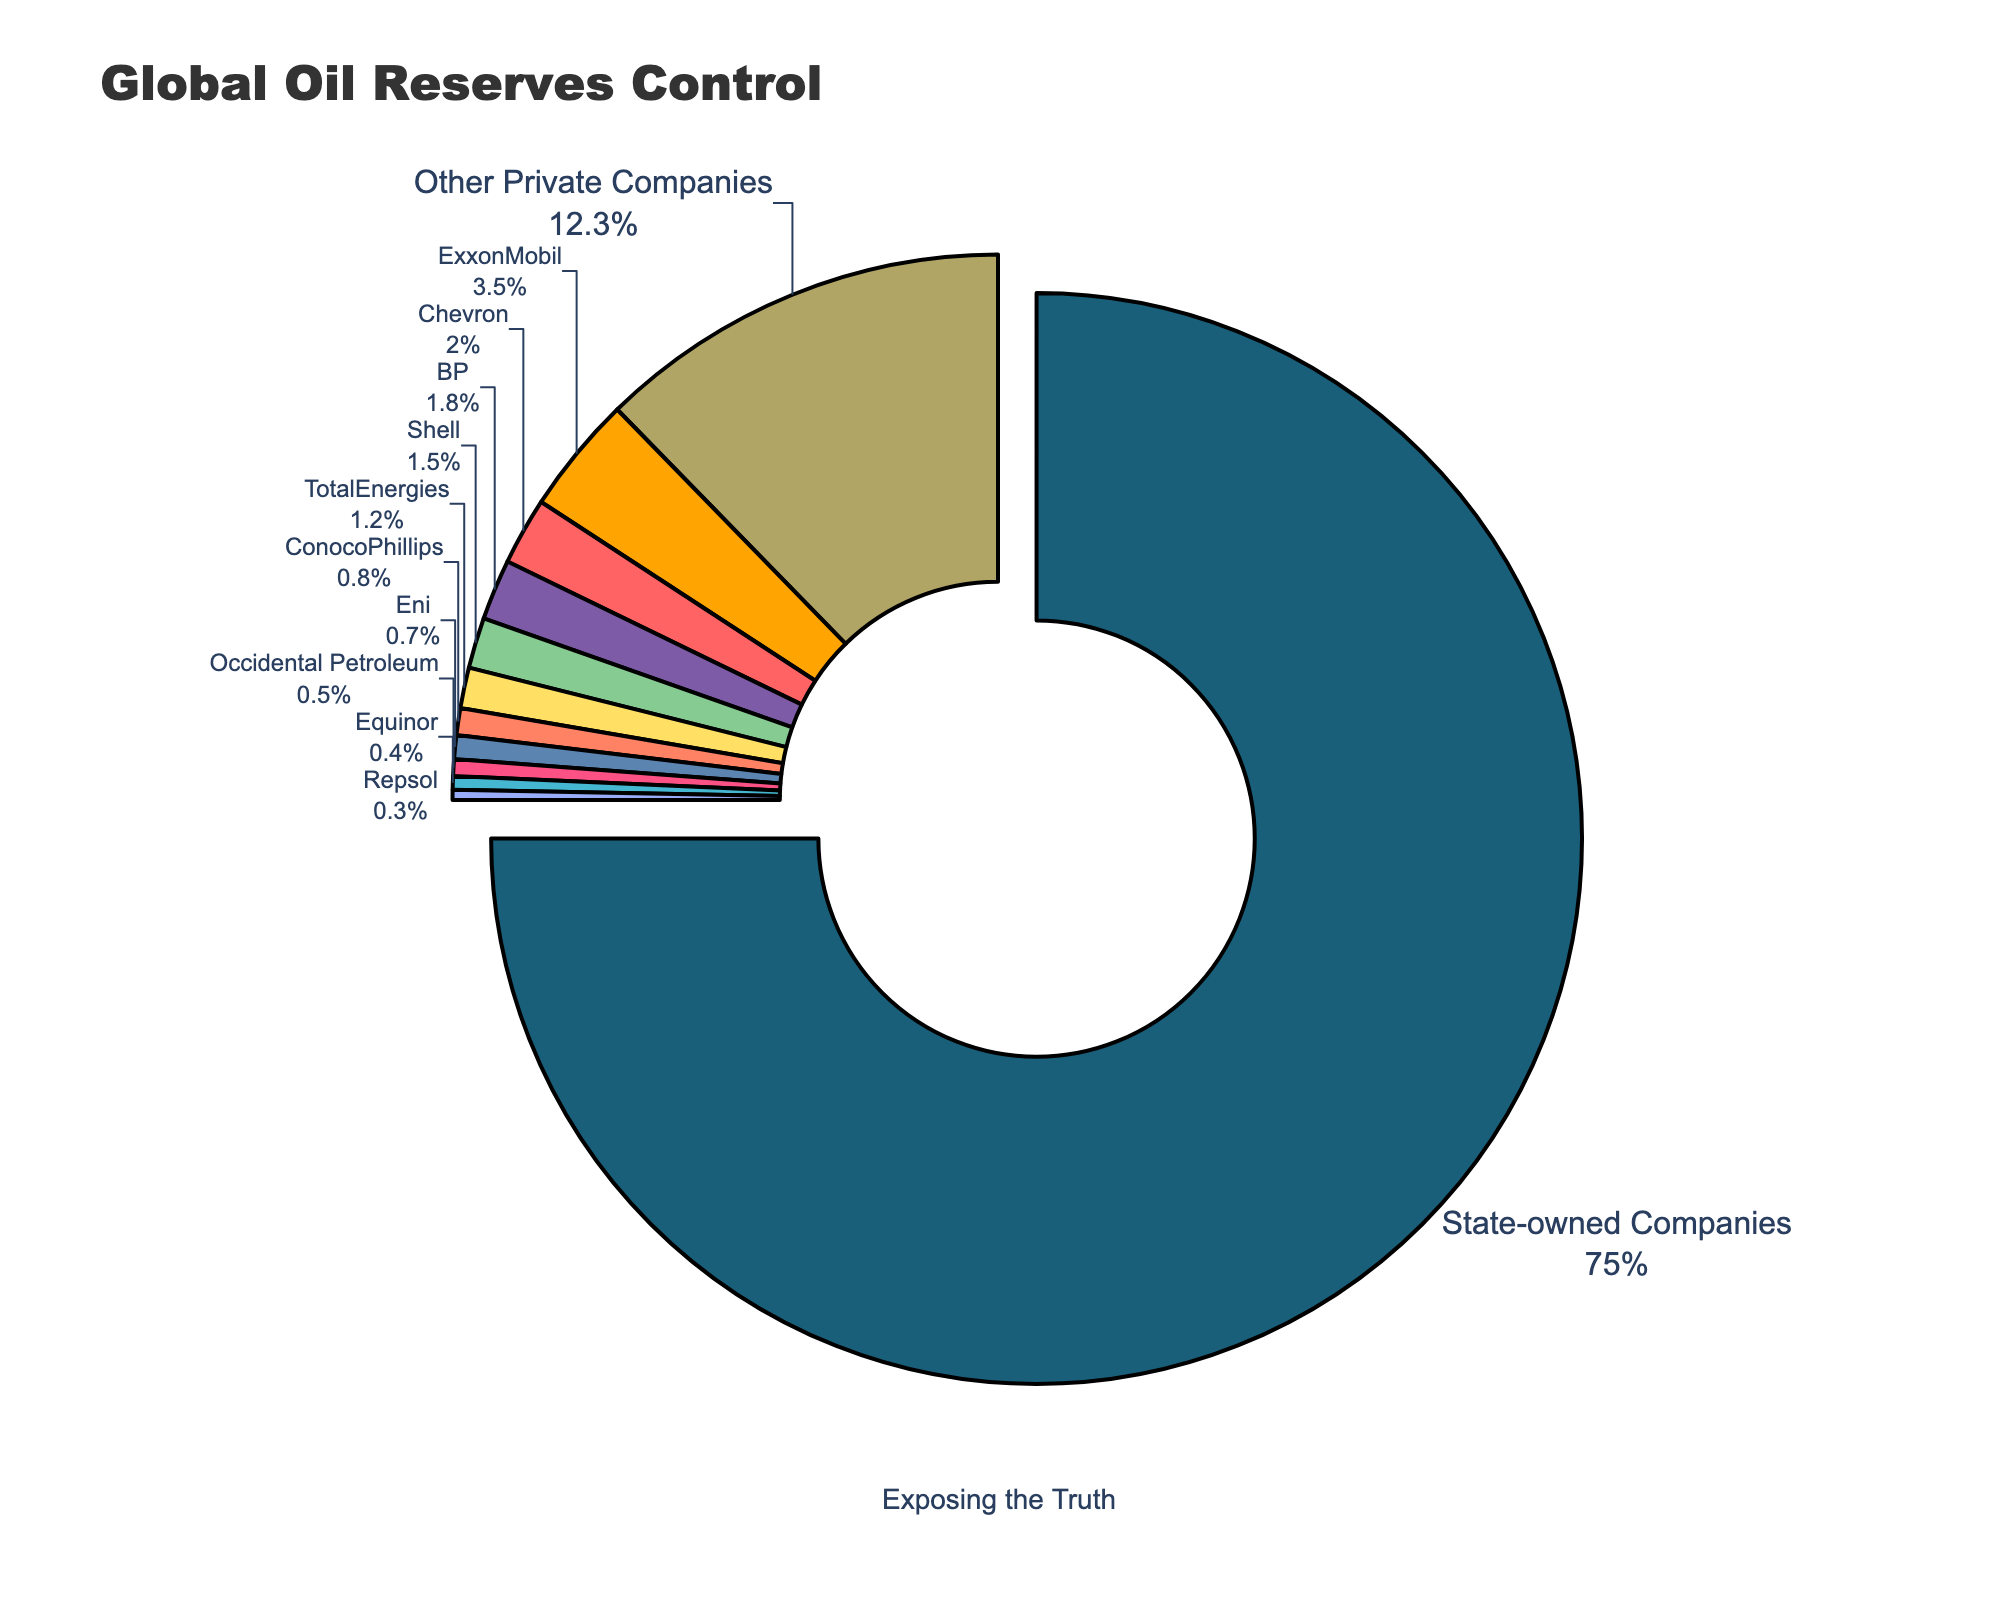What's the percentage of global oil reserves controlled by private companies? According to the chart, add up the percentages of private companies such as ExxonMobil, Chevron, BP, Shell, TotalEnergies, ConocoPhillips, Eni, Occidental Petroleum, Equinor, Repsol, and Other Private Companies. The total is 3.5 + 2 + 1.8 + 1.5 + 1.2 + 0.8 + 0.7 + 0.5 + 0.4 + 0.3 + 12.3, which is 25%.
Answer: 25% Which company controls the largest share of global oil reserves? From the chart, it's visually clear that "State-owned Companies" has the largest share, indicated by the largest section of the pie chart.
Answer: State-owned Companies How much larger is the share of oil reserves controlled by state-owned companies compared to ExxonMobil? State-owned Companies control 75%, and ExxonMobil controls 3.5%. The difference is 75% - 3.5% = 71.5%.
Answer: 71.5% What is the combined share of oil reserves controlled by TotalEnergies and BP? TotalEnergies controls 1.2% and BP controls 1.8%. Their combined share is 1.2% + 1.8% = 3%.
Answer: 3% Which non-state-owned company controls the smallest percentage of global oil reserves? Repsol controls the smallest percentage among non-state-owned companies at 0.3%.
Answer: Repsol What percentage of global oil reserves do the top three private companies control? The top three private companies by percentage are ExxonMobil (3.5%), Chevron (2%), and BP (1.8%). Their total is 3.5% + 2% + 1.8% = 7.3%.
Answer: 7.3% How does the share of oil reserves controlled by Shell compare to that controlled by ConocoPhillips? Shell controls 1.5% and ConocoPhillips controls 0.8%. Shell's share is larger than ConocoPhillips by 1.5% - 0.8% = 0.7%.
Answer: Shell's share is 0.7% larger Which company has a share closest in size to Occidental Petroleum? Occidental Petroleum has a share of 0.5%. Equinor has a share of 0.4%, which is closest.
Answer: Equinor What is the sum of the shares controlled by companies with less than 1%? Adding the shares of ConocoPhillips (0.8%), Eni (0.7%), Occidental Petroleum (0.5%), Equinor (0.4%), and Repsol (0.3%), the total is 0.8% + 0.7% + 0.5% + 0.4% + 0.3% = 2.7%.
Answer: 2.7% 